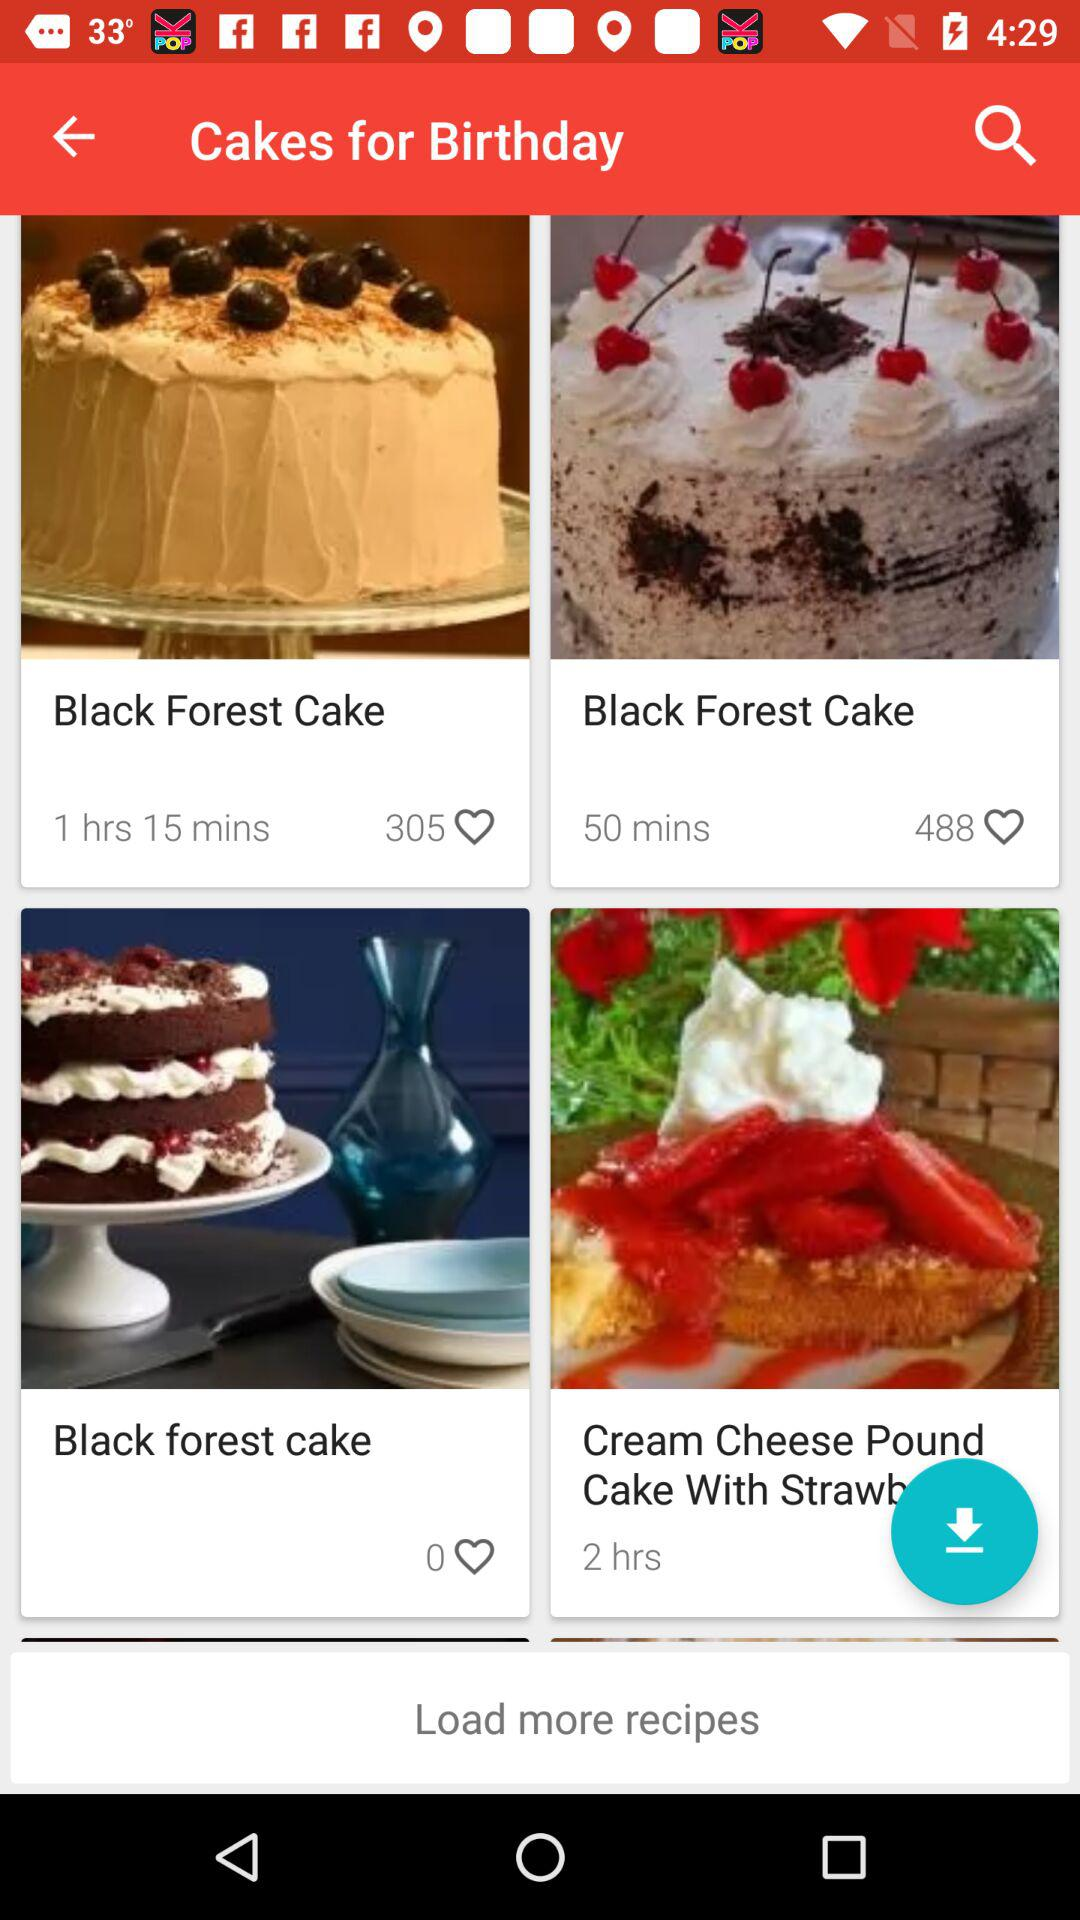Which cake has the highest rating?
Answer the question using a single word or phrase. Black Forest Cake 